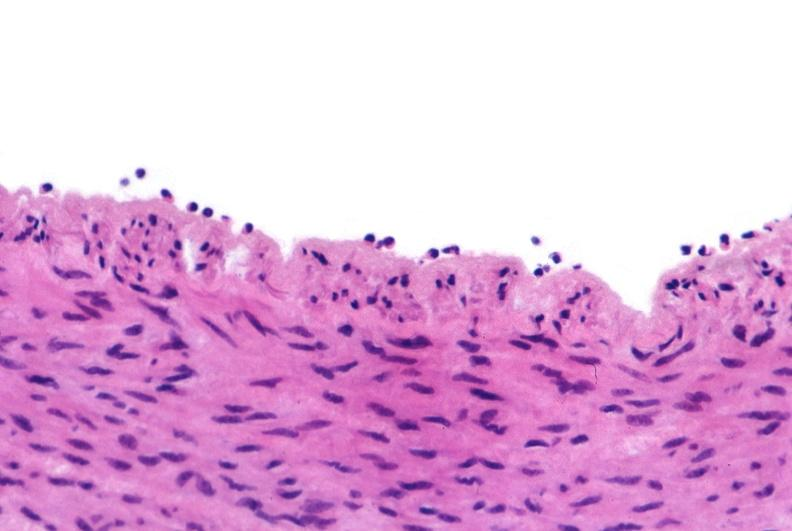where is this from?
Answer the question using a single word or phrase. Vasculature 